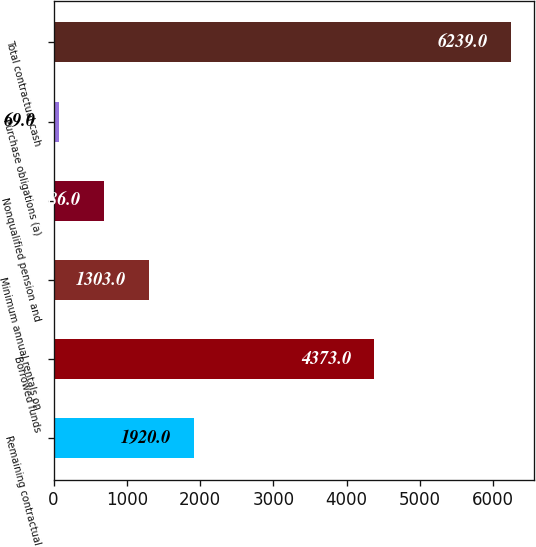Convert chart to OTSL. <chart><loc_0><loc_0><loc_500><loc_500><bar_chart><fcel>Remaining contractual<fcel>Borrowed funds<fcel>Minimum annual rentals on<fcel>Nonqualified pension and<fcel>Purchase obligations (a)<fcel>Total contractual cash<nl><fcel>1920<fcel>4373<fcel>1303<fcel>686<fcel>69<fcel>6239<nl></chart> 